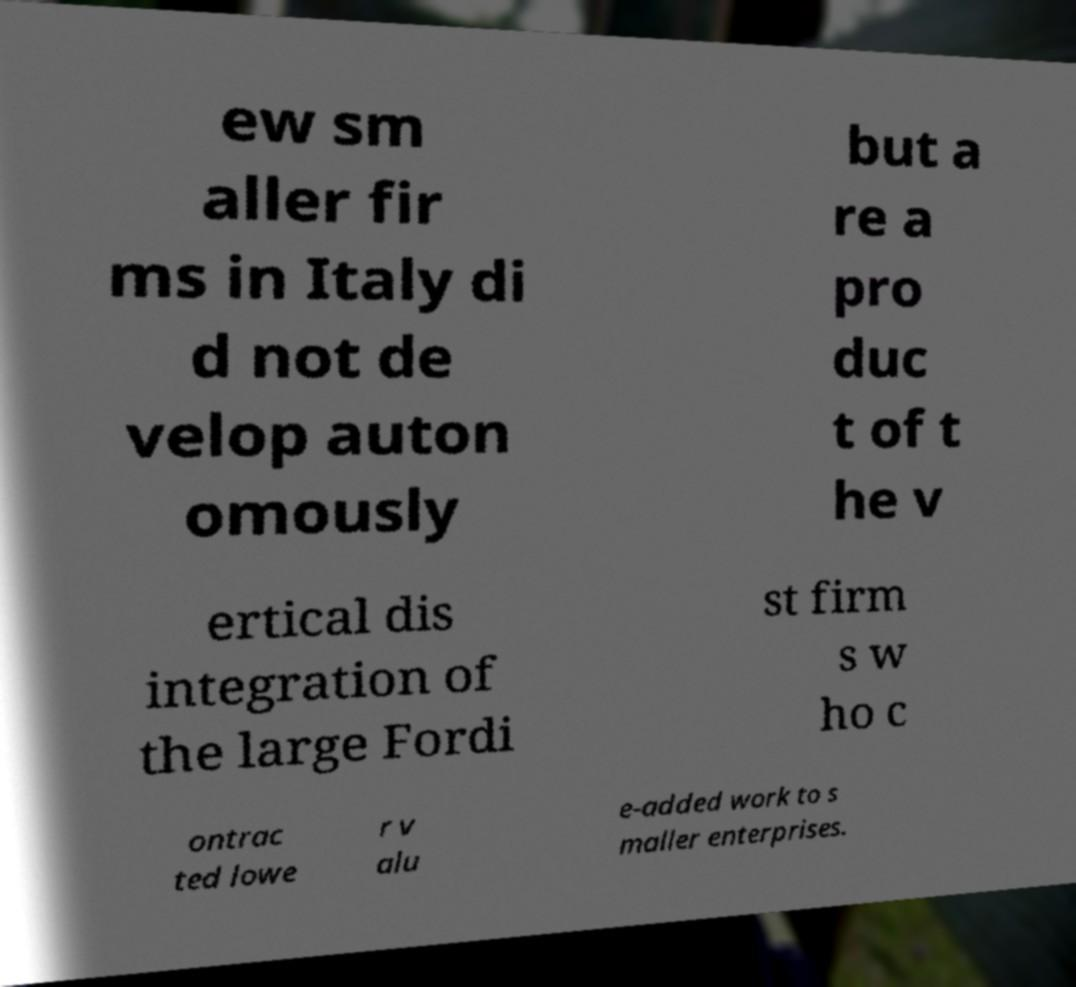Please identify and transcribe the text found in this image. ew sm aller fir ms in Italy di d not de velop auton omously but a re a pro duc t of t he v ertical dis integration of the large Fordi st firm s w ho c ontrac ted lowe r v alu e-added work to s maller enterprises. 